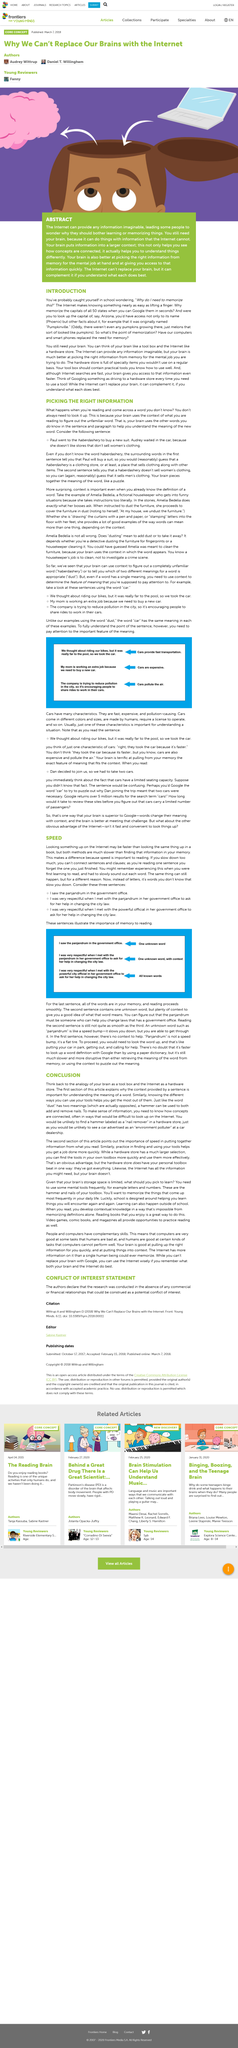Point out several critical features in this image. Looking up the same thing on the internet is faster than looking it up in a book. The conclusion compares the brain to a toolbox and the internet to a hardware store, emphasizing the importance of both as resources for problem-solving and learning. The conclusion drawn from the information provided is that an alternate name for a hammer is "nail remover. The internet is a main theme of this abstract, as it is discussed extensively in the paper. The title refers to information called "context". 